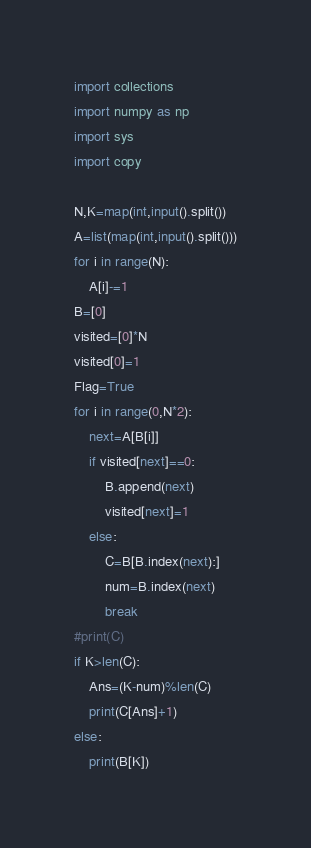Convert code to text. <code><loc_0><loc_0><loc_500><loc_500><_Python_>import collections
import numpy as np
import sys
import copy

N,K=map(int,input().split())
A=list(map(int,input().split()))
for i in range(N):
    A[i]-=1
B=[0]
visited=[0]*N
visited[0]=1
Flag=True
for i in range(0,N*2):
    next=A[B[i]]
    if visited[next]==0:
        B.append(next)
        visited[next]=1
    else:
        C=B[B.index(next):]
        num=B.index(next)
        break
#print(C)
if K>len(C):
    Ans=(K-num)%len(C)
    print(C[Ans]+1)
else:
    print(B[K])</code> 